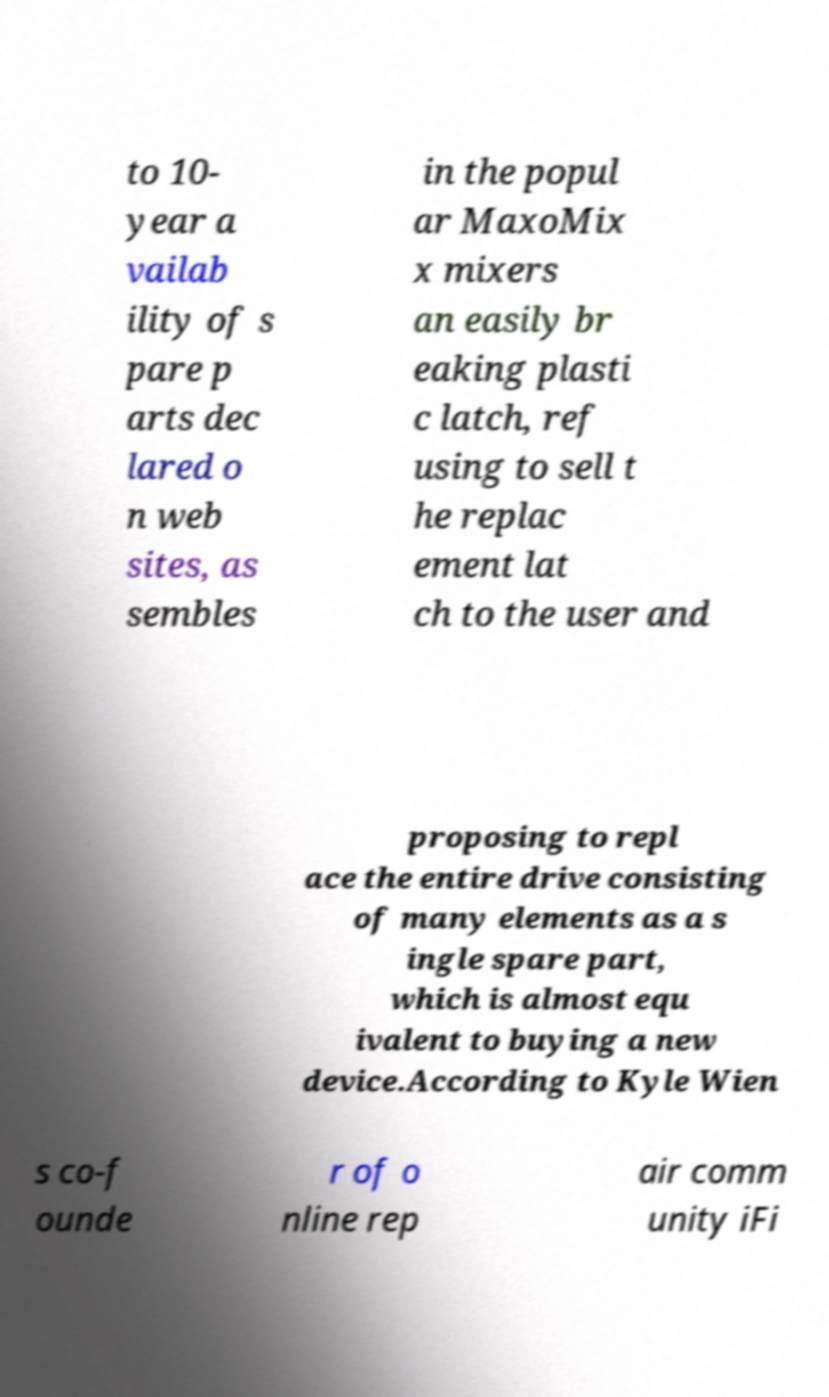For documentation purposes, I need the text within this image transcribed. Could you provide that? to 10- year a vailab ility of s pare p arts dec lared o n web sites, as sembles in the popul ar MaxoMix x mixers an easily br eaking plasti c latch, ref using to sell t he replac ement lat ch to the user and proposing to repl ace the entire drive consisting of many elements as a s ingle spare part, which is almost equ ivalent to buying a new device.According to Kyle Wien s co-f ounde r of o nline rep air comm unity iFi 